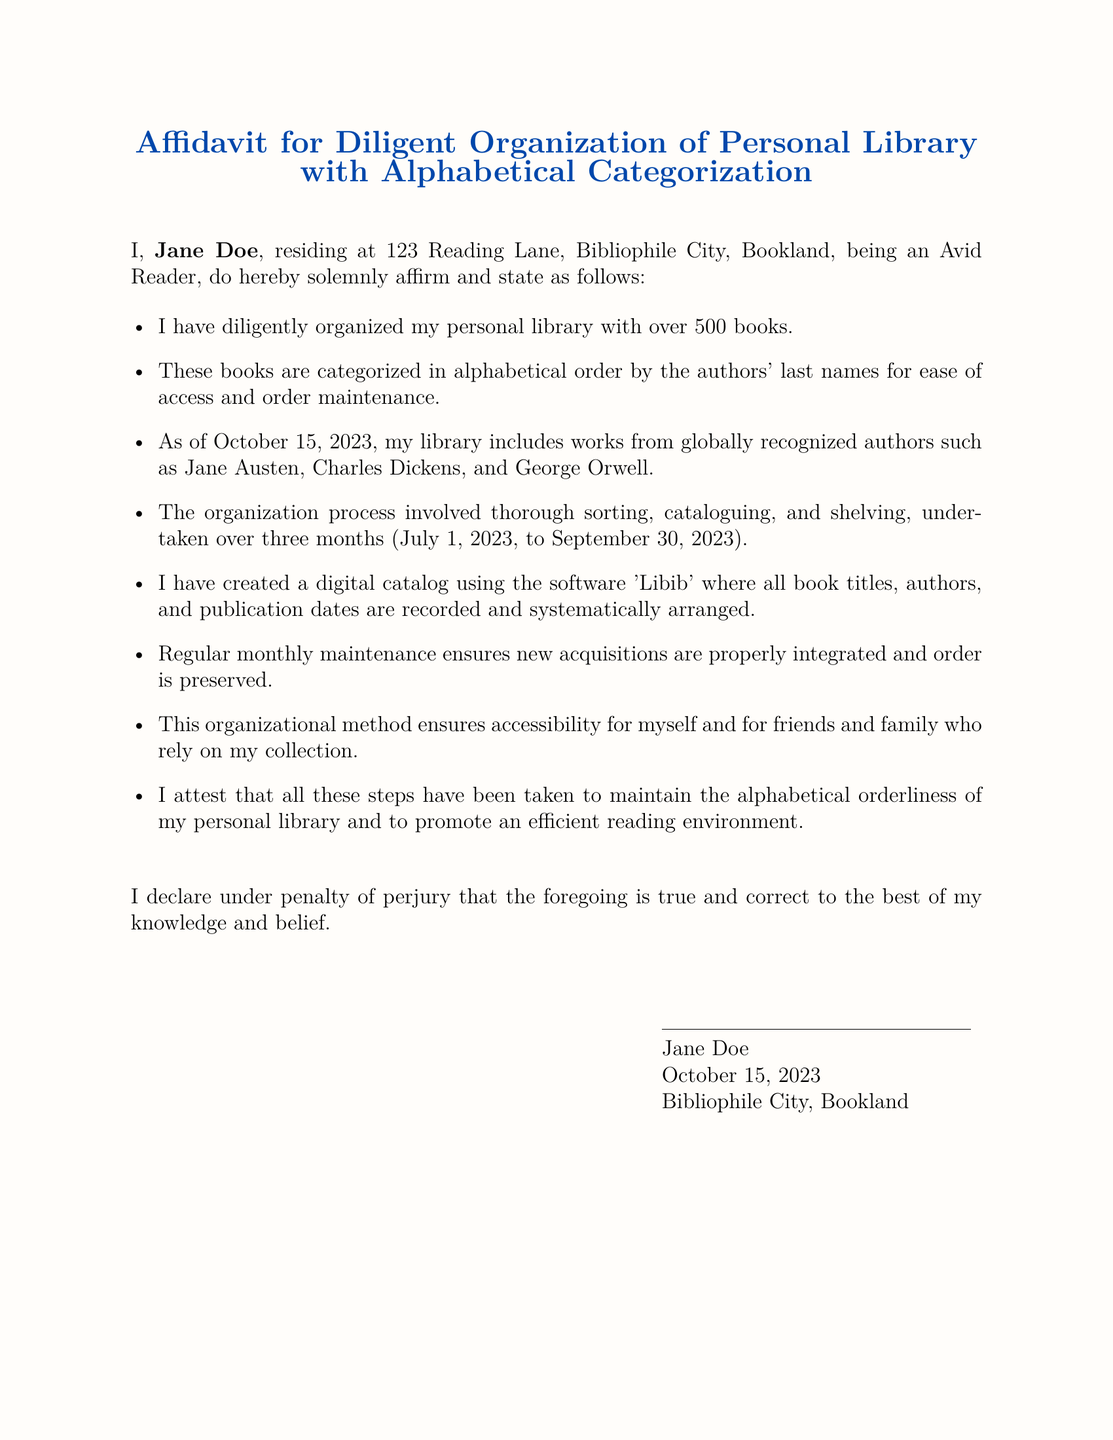What is the name of the affiant? The affiant is the person who makes an oath or affirmation in the affidavit, which in this case is stated as Jane Doe.
Answer: Jane Doe How many books are in the personal library? The document states the number of books organized in the personal library, which is given as over 500.
Answer: over 500 What software is used for cataloging the books? The software used for cataloging the books in the affidavit is mentioned as 'Libib'.
Answer: Libib What is the date of the affidavit? The affidavit includes a declaration dated October 15, 2023.
Answer: October 15, 2023 How long did the organization process take? The affidavit specifies the duration of the organization process as three months, from July 1, 2023, to September 30, 2023.
Answer: three months What does the alphabetical organization promote? The affidavit mentions that maintaining the alphabetical order promotes an efficient reading environment.
Answer: efficient reading environment What is the purpose of the regular monthly maintenance? The affidavit describes that regular monthly maintenance ensures new acquisitions are properly integrated and order is preserved.
Answer: order is preserved In what format is the declaration made by the affiant? The declaration is made under penalty of perjury, indicating a legal affirmation of truthfulness.
Answer: under penalty of perjury What method is used for organizing the library? The organization method specified in the affidavit involves sorting, cataloguing, and shelving by authors' last names.
Answer: sorting, cataloguing, and shelving 